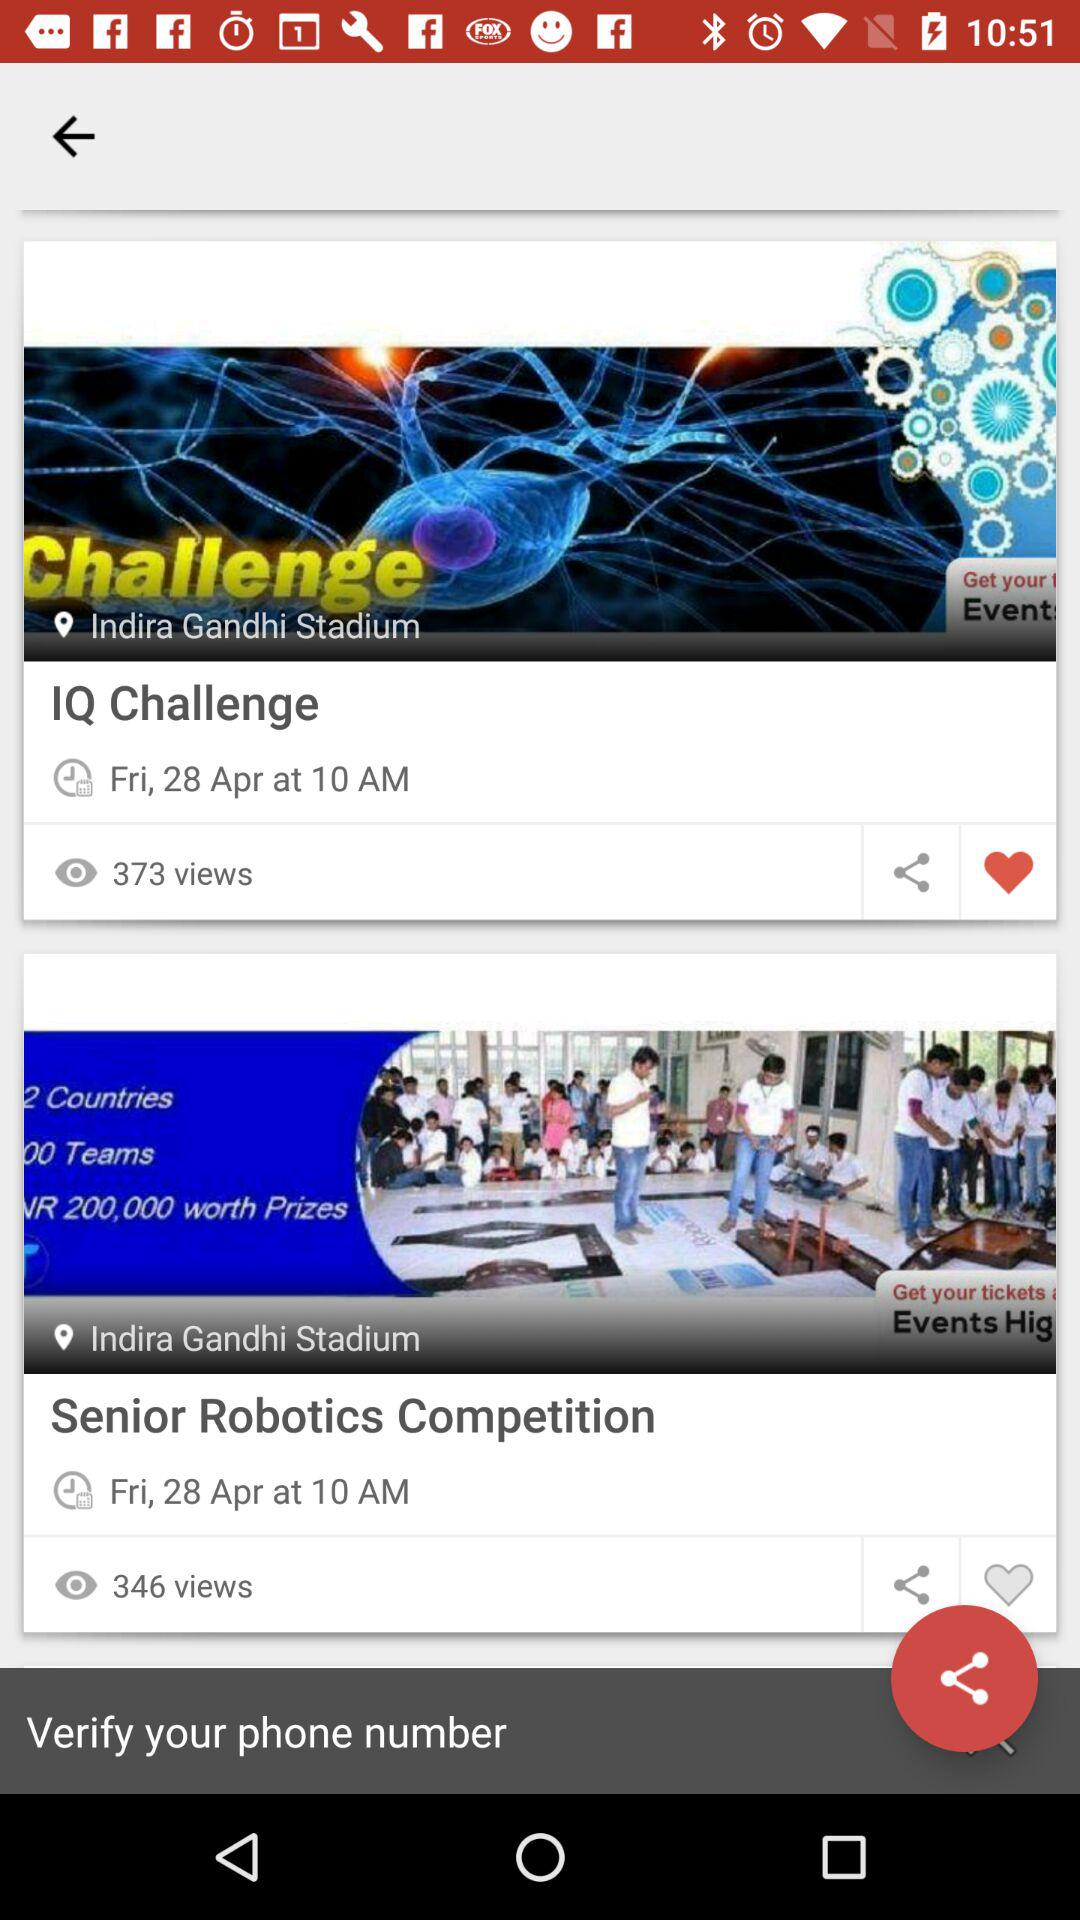What is the time of the "Senior Robotics Competition"? The time is 10 a.m. 